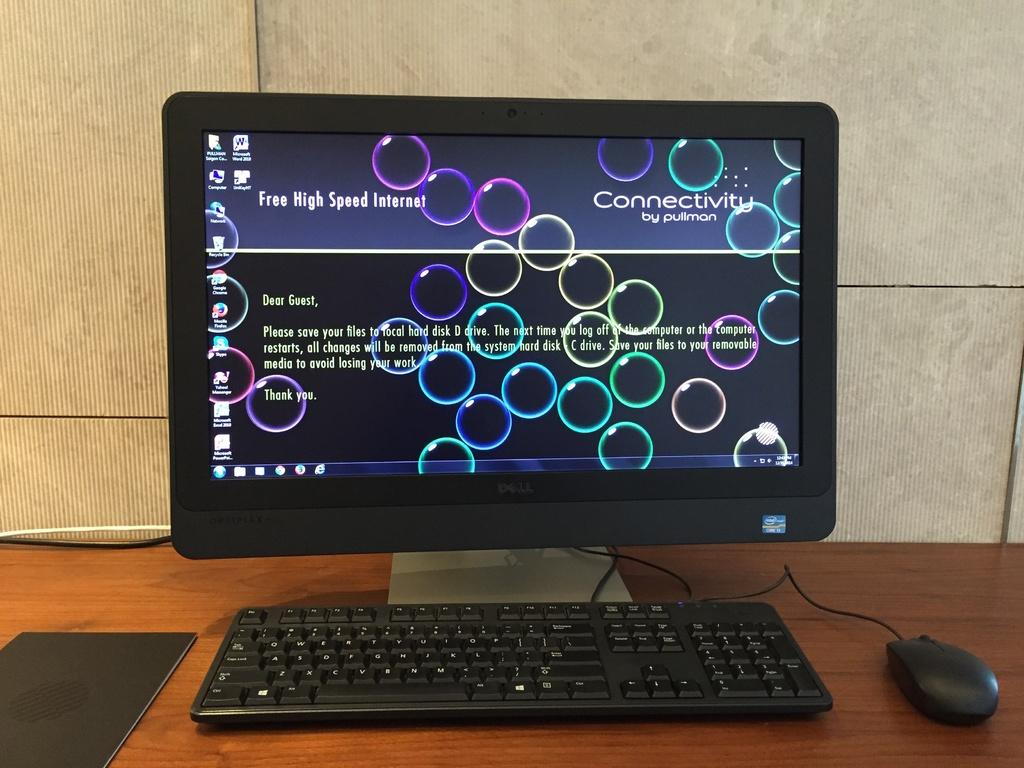<image>
Provide a brief description of the given image. A computer with an Intel Core i3 processor is on a screen about Connectivity. 